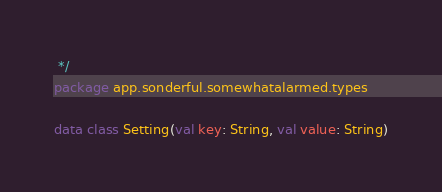Convert code to text. <code><loc_0><loc_0><loc_500><loc_500><_Kotlin_> */
package app.sonderful.somewhatalarmed.types

data class Setting(val key: String, val value: String)</code> 